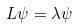Convert formula to latex. <formula><loc_0><loc_0><loc_500><loc_500>L \psi = \lambda \psi</formula> 